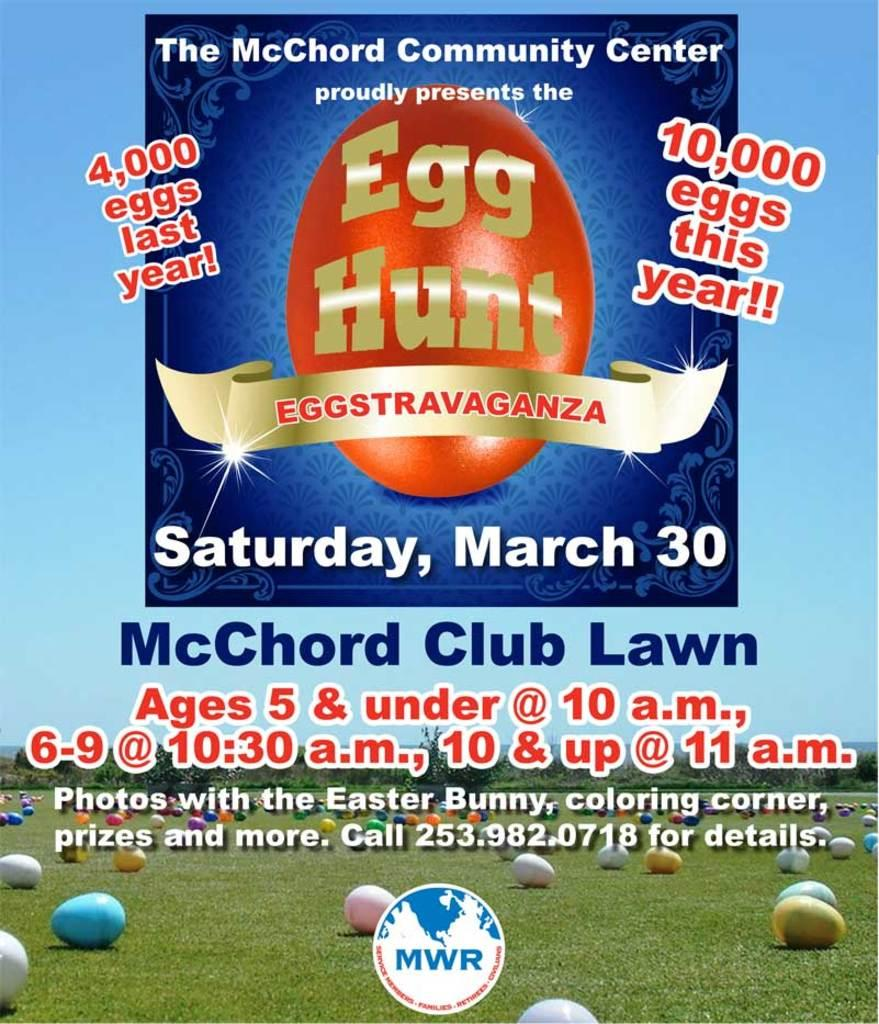<image>
Share a concise interpretation of the image provided. An advertisement for an egg hunt gives times and the date of the event. 